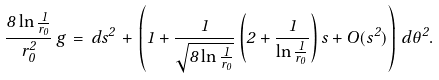Convert formula to latex. <formula><loc_0><loc_0><loc_500><loc_500>\frac { 8 \ln \frac { 1 } { r _ { 0 } } } { r _ { 0 } ^ { 2 } } \, g \, = \, d s ^ { 2 } \, + \, \left ( 1 + { \frac { 1 } { \sqrt { 8 \ln \frac { 1 } { r _ { 0 } } } } } \left ( 2 + \frac { 1 } { \ln \frac { 1 } { r _ { 0 } } } \right ) s + O ( s ^ { 2 } ) \right ) \, d \theta ^ { 2 } .</formula> 